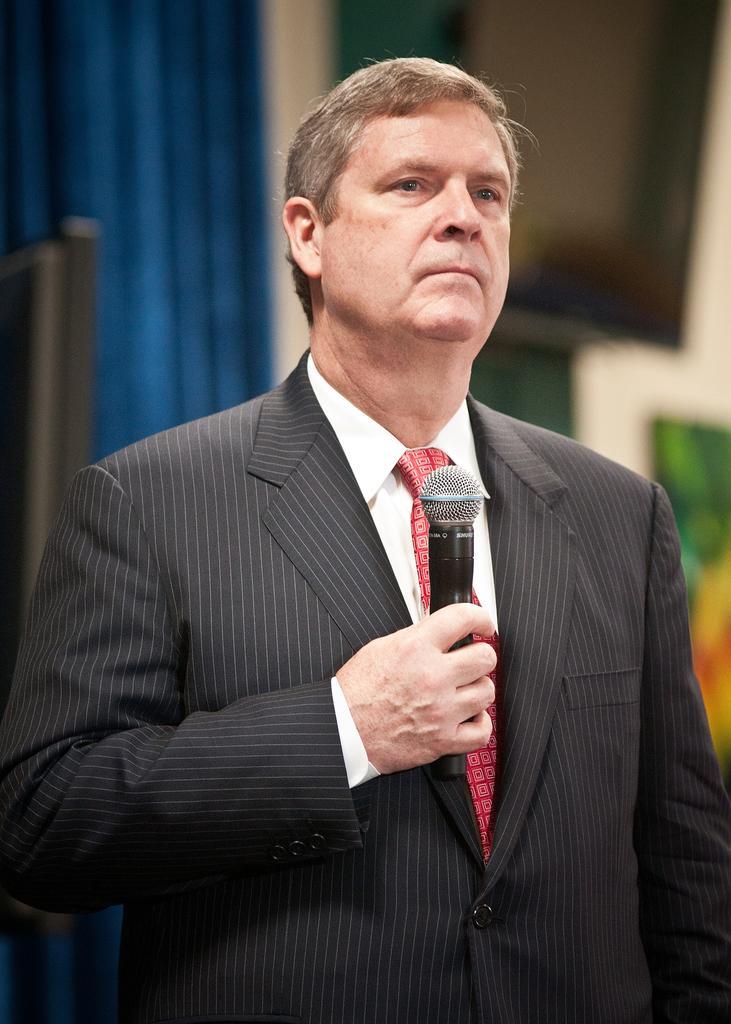Describe this image in one or two sentences. In this image there is a man wearing a black color blazer,white shirt , red tie holding a microphone and the background there is curtain. 